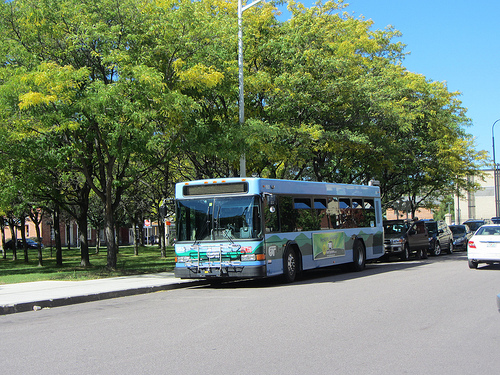What is in front of the green tree? In front of the green tree, there is a bus. 